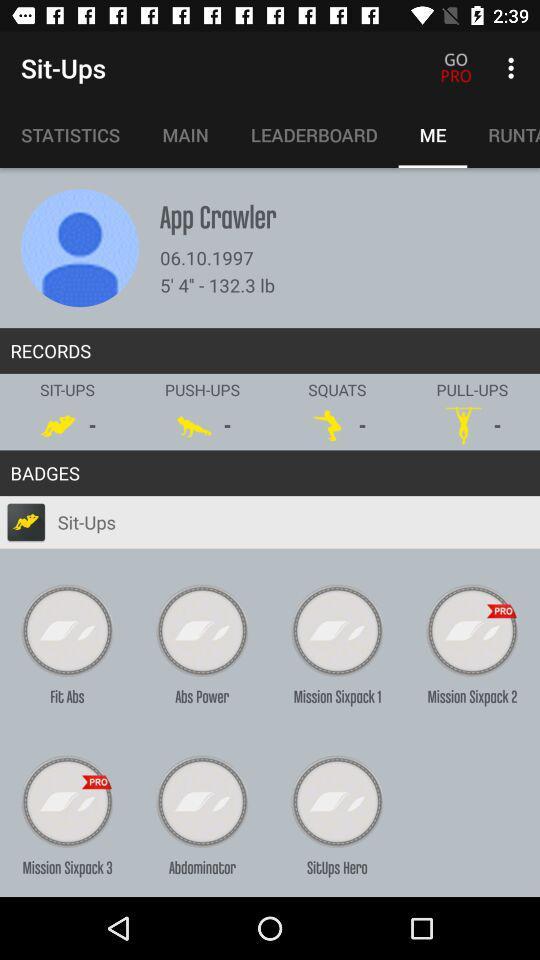Which tab is selected? The selected tab is "ME". 